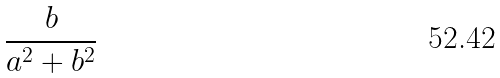Convert formula to latex. <formula><loc_0><loc_0><loc_500><loc_500>\frac { b } { a ^ { 2 } + b ^ { 2 } }</formula> 